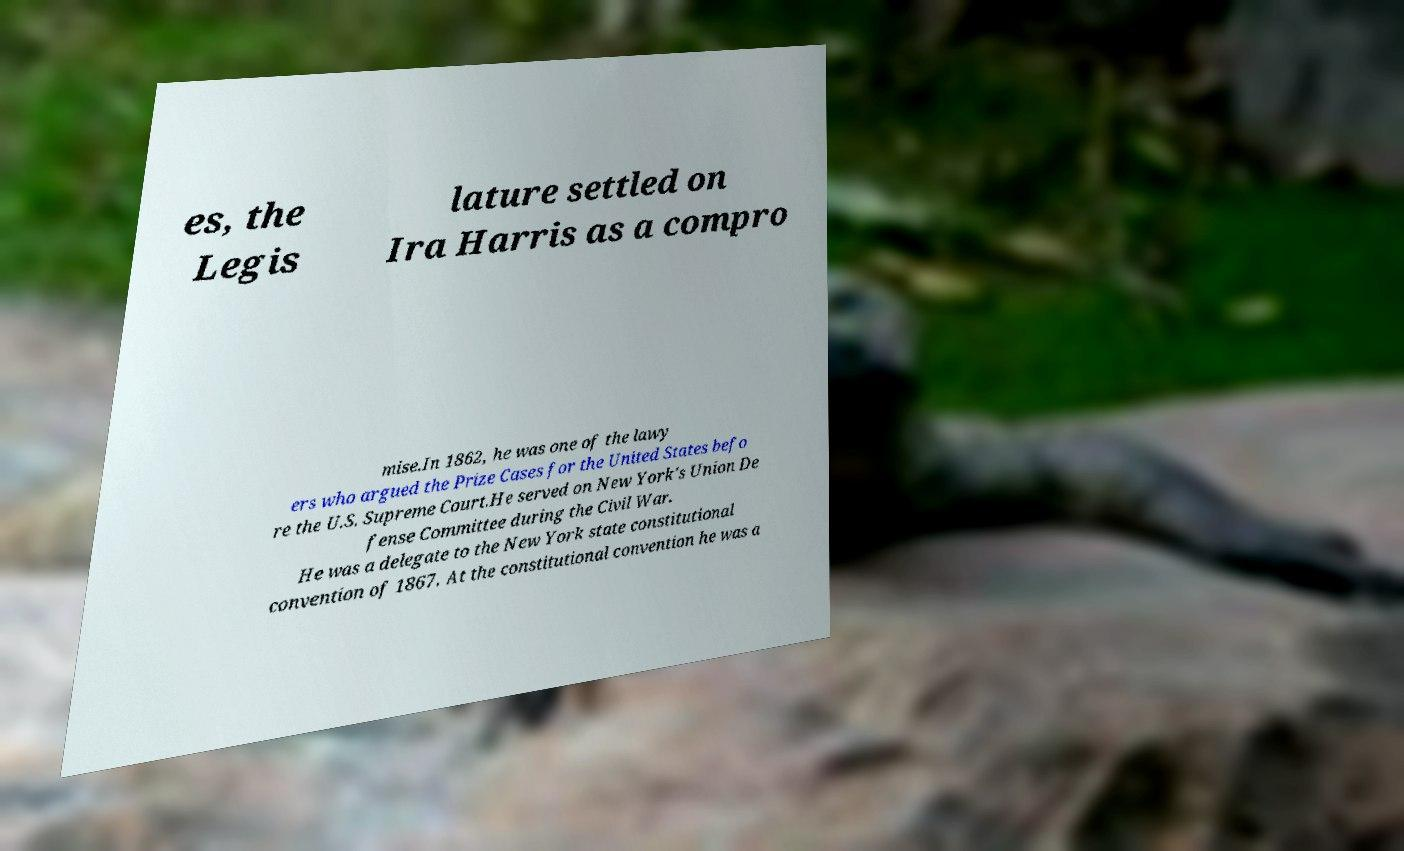Please identify and transcribe the text found in this image. es, the Legis lature settled on Ira Harris as a compro mise.In 1862, he was one of the lawy ers who argued the Prize Cases for the United States befo re the U.S. Supreme Court.He served on New York's Union De fense Committee during the Civil War. He was a delegate to the New York state constitutional convention of 1867. At the constitutional convention he was a 